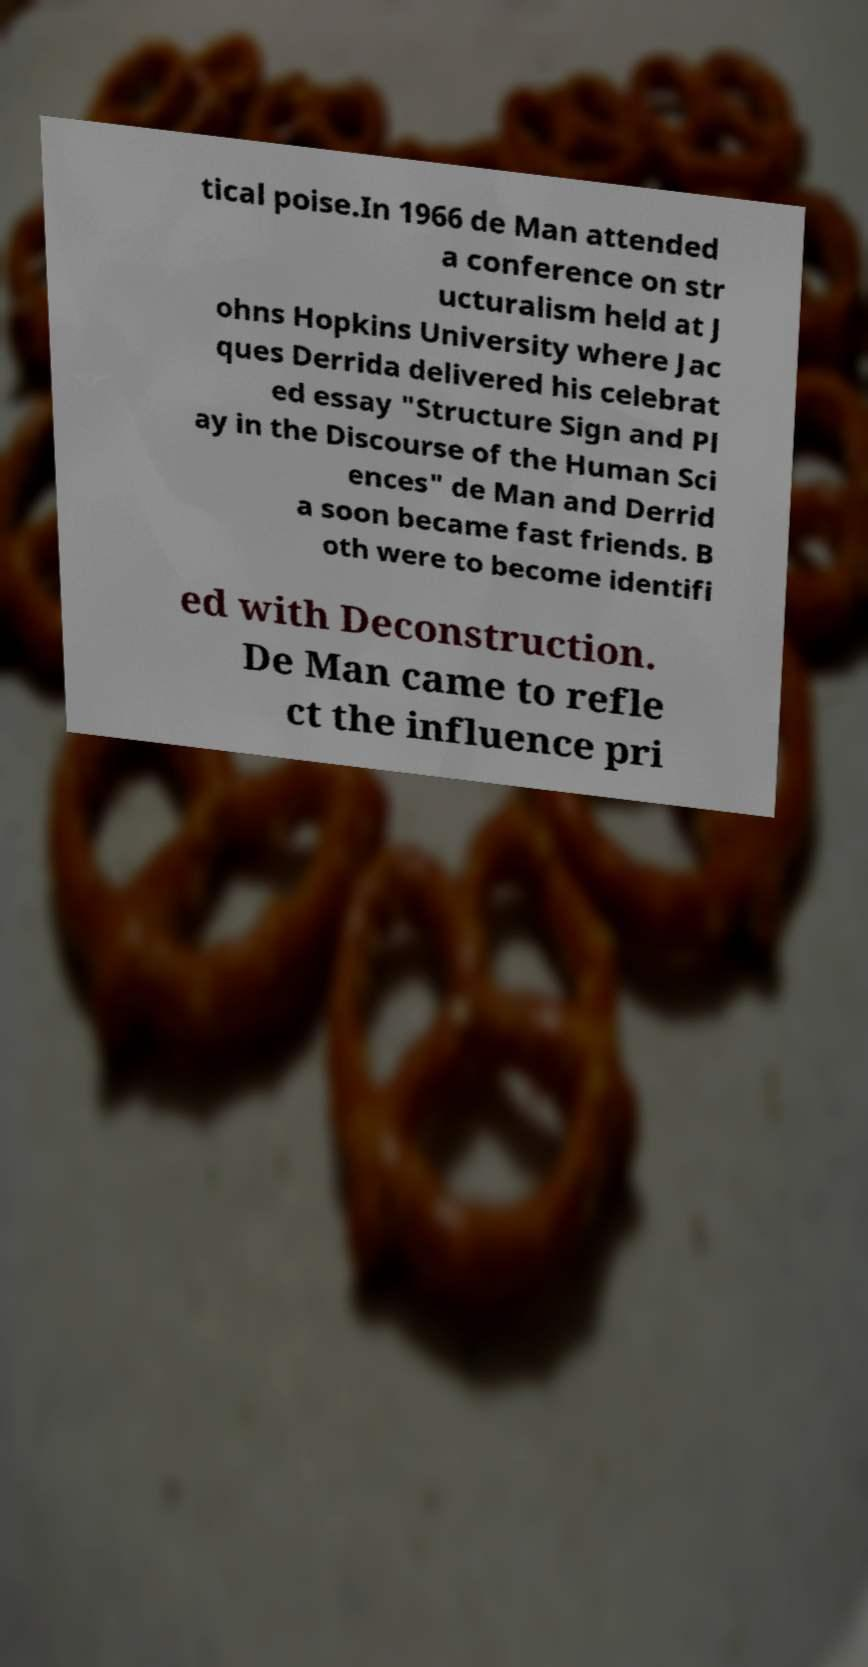Could you extract and type out the text from this image? tical poise.In 1966 de Man attended a conference on str ucturalism held at J ohns Hopkins University where Jac ques Derrida delivered his celebrat ed essay "Structure Sign and Pl ay in the Discourse of the Human Sci ences" de Man and Derrid a soon became fast friends. B oth were to become identifi ed with Deconstruction. De Man came to refle ct the influence pri 